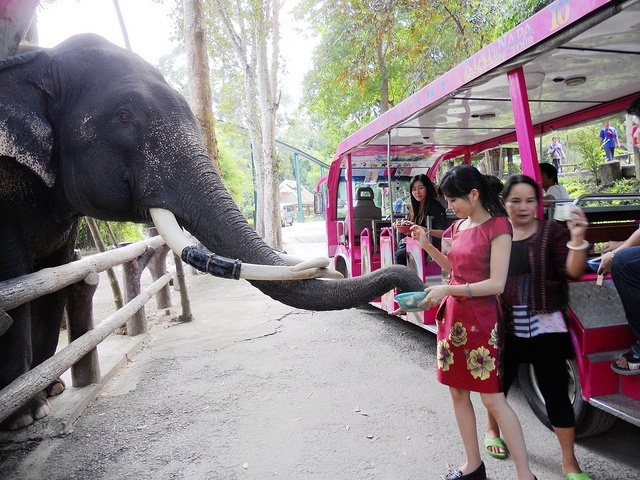Describe the objects in this image and their specific colors. I can see bus in purple, darkgray, black, gray, and maroon tones, elephant in purple, black, gray, and darkgray tones, people in purple, maroon, gray, darkgray, and black tones, people in purple, black, gray, and darkgray tones, and people in purple, black, gray, navy, and darkgray tones in this image. 